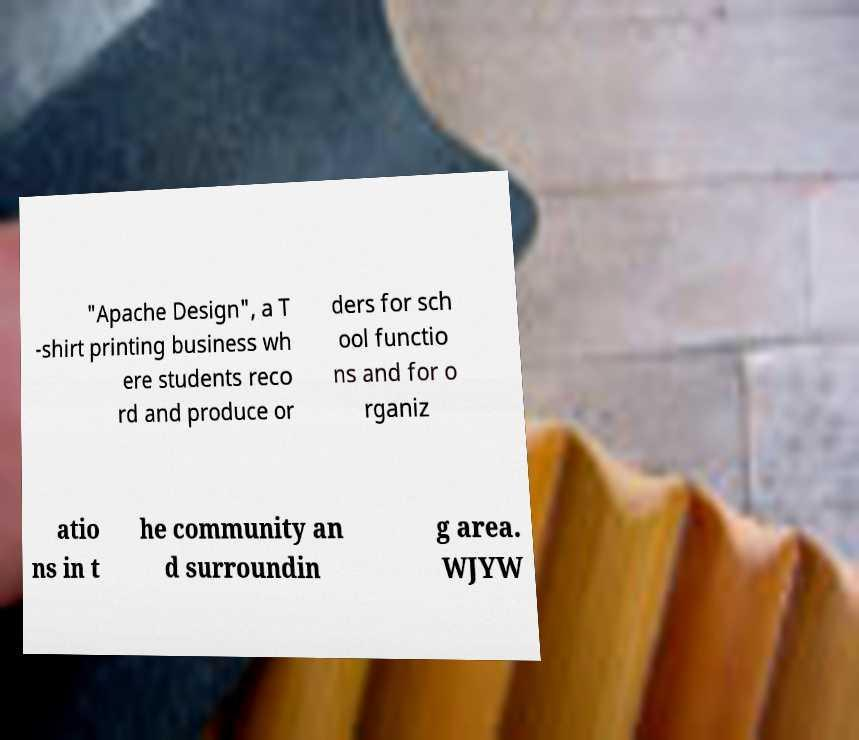Please read and relay the text visible in this image. What does it say? "Apache Design", a T -shirt printing business wh ere students reco rd and produce or ders for sch ool functio ns and for o rganiz atio ns in t he community an d surroundin g area. WJYW 